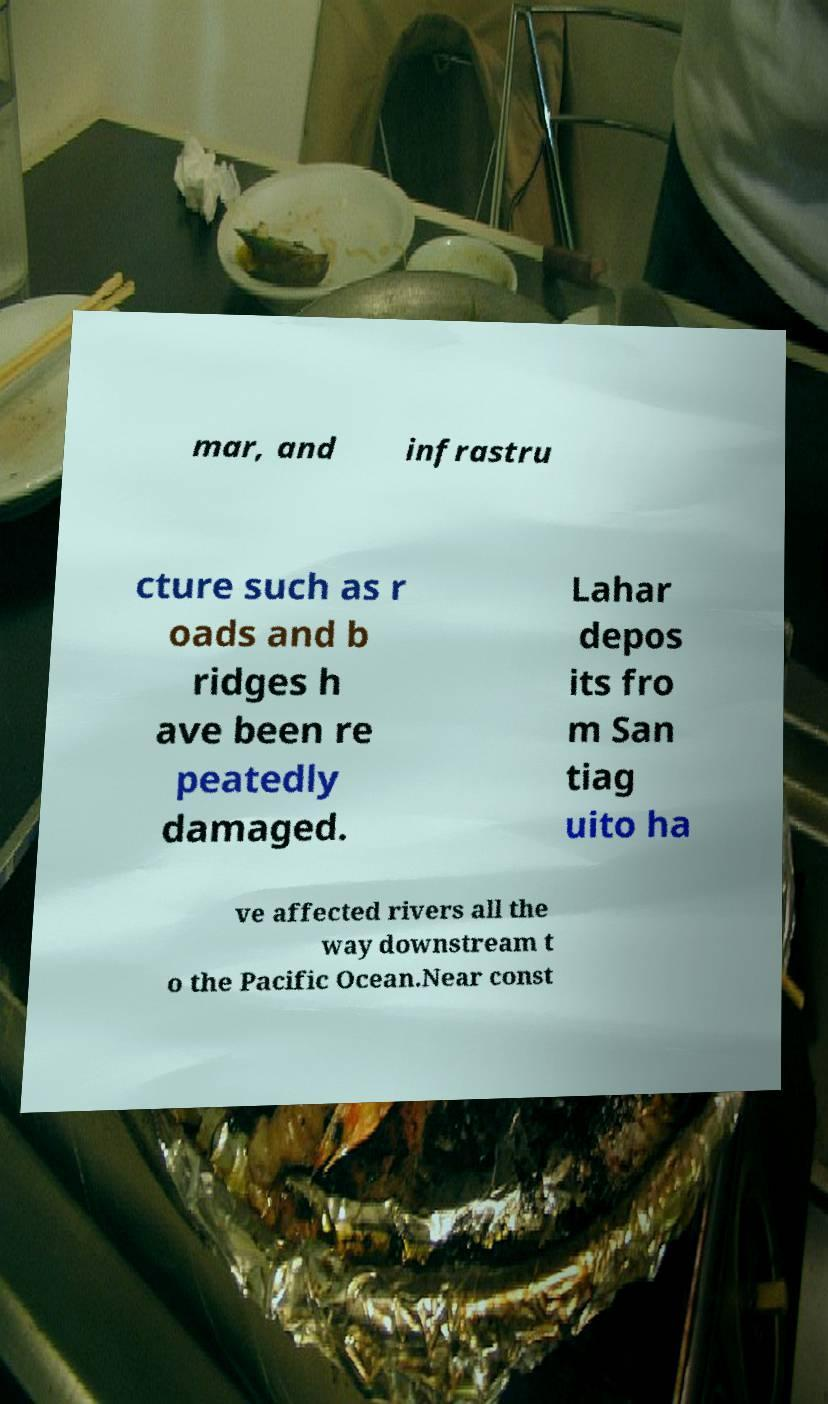Can you read and provide the text displayed in the image?This photo seems to have some interesting text. Can you extract and type it out for me? mar, and infrastru cture such as r oads and b ridges h ave been re peatedly damaged. Lahar depos its fro m San tiag uito ha ve affected rivers all the way downstream t o the Pacific Ocean.Near const 